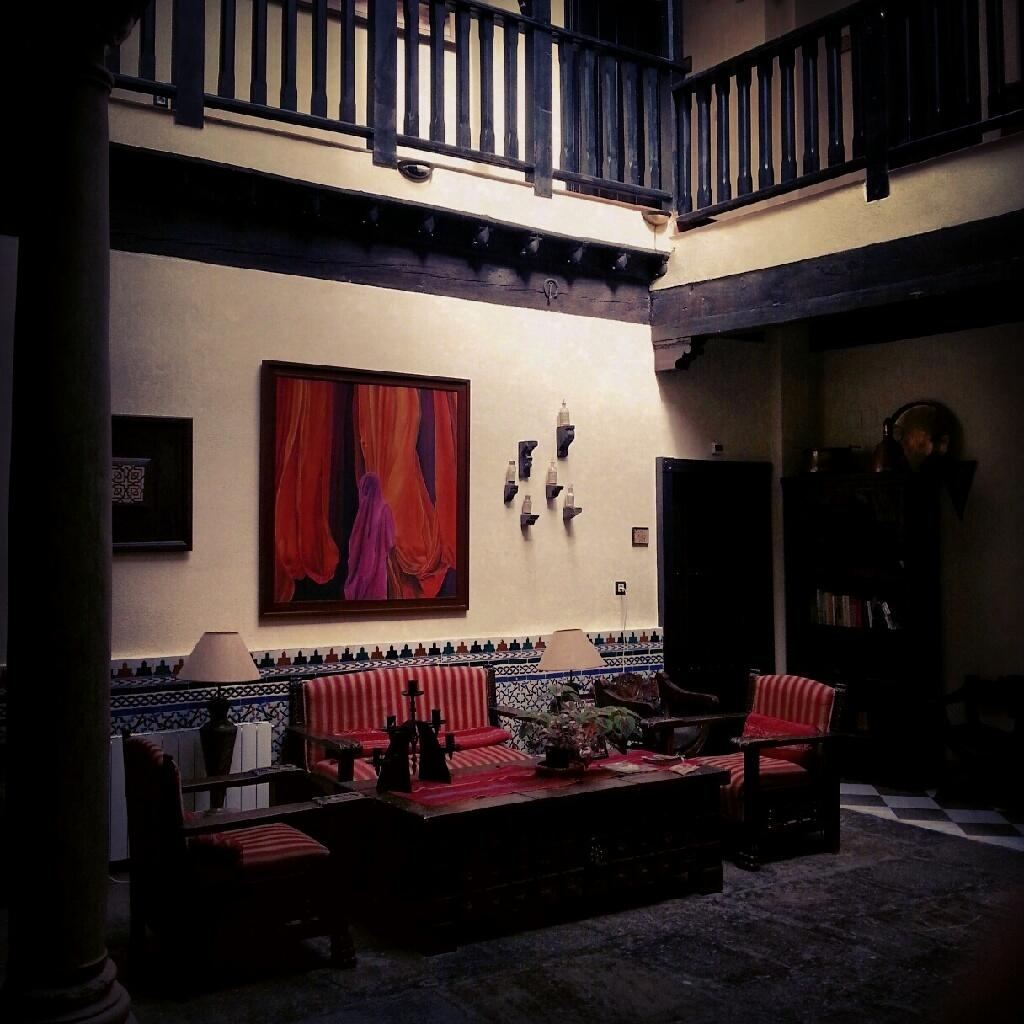What type of lighting fixture is present in the image? There is a lamp in the image. What type of seating is present in the image? There is a sofa and a chair in the image. What type of decorative item is present in the image? There is a frame in the image. What type of storage item is present in the image? There are bottles on a wooden plank and books in a cupboard in the image. What type of floor covering is present in the image? There is a carpet on the floor in the image. What type of instrument is being played by the lamp in the image? There is no instrument being played by the lamp in the image; it is a lighting fixture. How does the carpet fold in the image? The carpet does not fold in the image; it is a flat floor covering. 